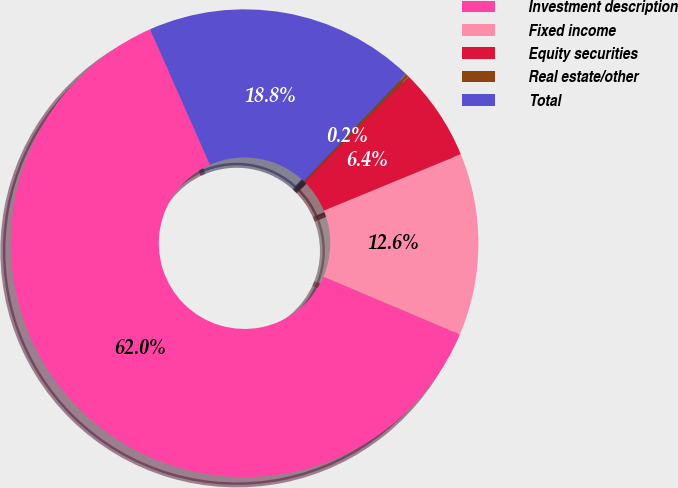<chart> <loc_0><loc_0><loc_500><loc_500><pie_chart><fcel>Investment description<fcel>Fixed income<fcel>Equity securities<fcel>Real estate/other<fcel>Total<nl><fcel>62.01%<fcel>12.59%<fcel>6.41%<fcel>0.23%<fcel>18.76%<nl></chart> 